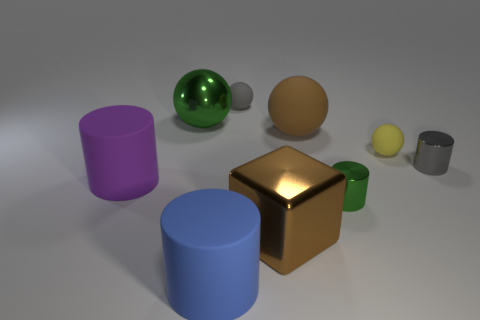How many gray rubber spheres have the same size as the blue thing?
Provide a succinct answer. 0. There is a big cube that is the same material as the big green thing; what color is it?
Your response must be concise. Brown. Are there fewer tiny yellow rubber things in front of the metallic block than tiny purple shiny objects?
Your answer should be very brief. No. There is a tiny gray thing that is made of the same material as the large brown ball; what is its shape?
Make the answer very short. Sphere. What number of rubber things are large blue things or small brown objects?
Your answer should be compact. 1. Are there the same number of small spheres left of the large purple thing and purple matte things?
Ensure brevity in your answer.  No. Is the color of the large sphere that is right of the cube the same as the large cube?
Your response must be concise. Yes. There is a tiny object that is behind the gray cylinder and in front of the tiny gray rubber object; what is it made of?
Offer a very short reply. Rubber. Is there a gray cylinder on the right side of the rubber cylinder on the right side of the green sphere?
Offer a terse response. Yes. Is the brown block made of the same material as the big blue cylinder?
Your answer should be very brief. No. 